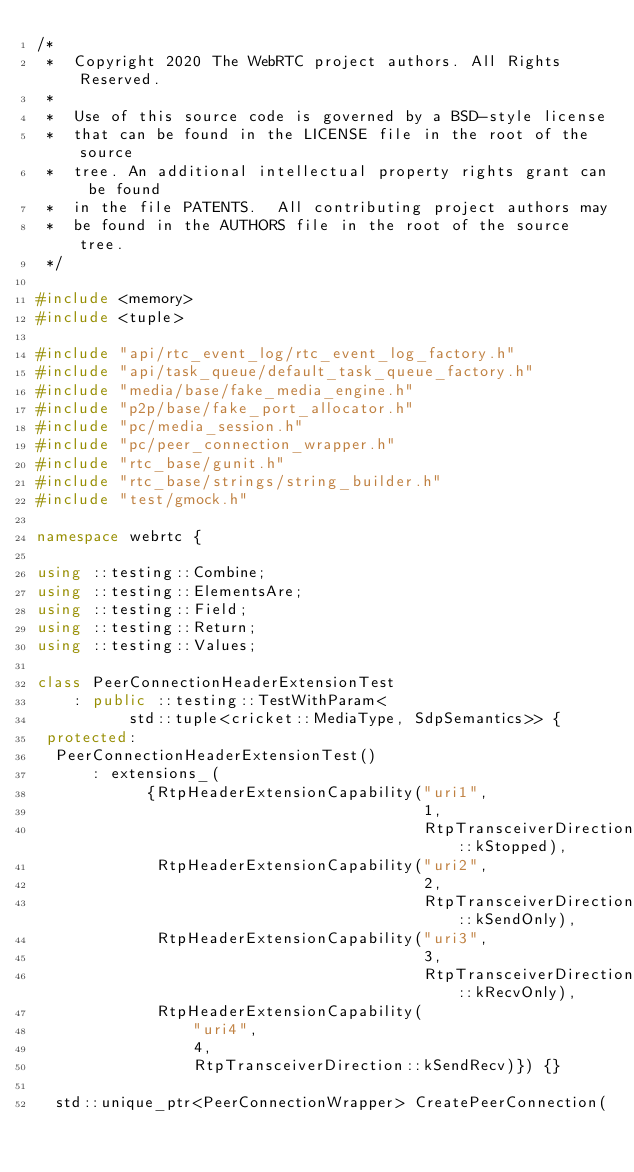<code> <loc_0><loc_0><loc_500><loc_500><_C++_>/*
 *  Copyright 2020 The WebRTC project authors. All Rights Reserved.
 *
 *  Use of this source code is governed by a BSD-style license
 *  that can be found in the LICENSE file in the root of the source
 *  tree. An additional intellectual property rights grant can be found
 *  in the file PATENTS.  All contributing project authors may
 *  be found in the AUTHORS file in the root of the source tree.
 */

#include <memory>
#include <tuple>

#include "api/rtc_event_log/rtc_event_log_factory.h"
#include "api/task_queue/default_task_queue_factory.h"
#include "media/base/fake_media_engine.h"
#include "p2p/base/fake_port_allocator.h"
#include "pc/media_session.h"
#include "pc/peer_connection_wrapper.h"
#include "rtc_base/gunit.h"
#include "rtc_base/strings/string_builder.h"
#include "test/gmock.h"

namespace webrtc {

using ::testing::Combine;
using ::testing::ElementsAre;
using ::testing::Field;
using ::testing::Return;
using ::testing::Values;

class PeerConnectionHeaderExtensionTest
    : public ::testing::TestWithParam<
          std::tuple<cricket::MediaType, SdpSemantics>> {
 protected:
  PeerConnectionHeaderExtensionTest()
      : extensions_(
            {RtpHeaderExtensionCapability("uri1",
                                          1,
                                          RtpTransceiverDirection::kStopped),
             RtpHeaderExtensionCapability("uri2",
                                          2,
                                          RtpTransceiverDirection::kSendOnly),
             RtpHeaderExtensionCapability("uri3",
                                          3,
                                          RtpTransceiverDirection::kRecvOnly),
             RtpHeaderExtensionCapability(
                 "uri4",
                 4,
                 RtpTransceiverDirection::kSendRecv)}) {}

  std::unique_ptr<PeerConnectionWrapper> CreatePeerConnection(</code> 